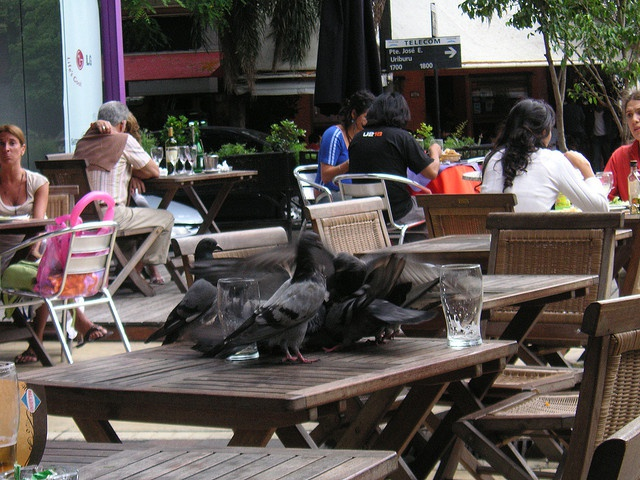Describe the objects in this image and their specific colors. I can see dining table in darkgreen, black, gray, and darkgray tones, chair in darkgreen, black, gray, and maroon tones, chair in darkgreen, maroon, black, and gray tones, chair in darkgreen, lightgray, gray, and darkgray tones, and people in darkgreen, lightgray, black, darkgray, and gray tones in this image. 